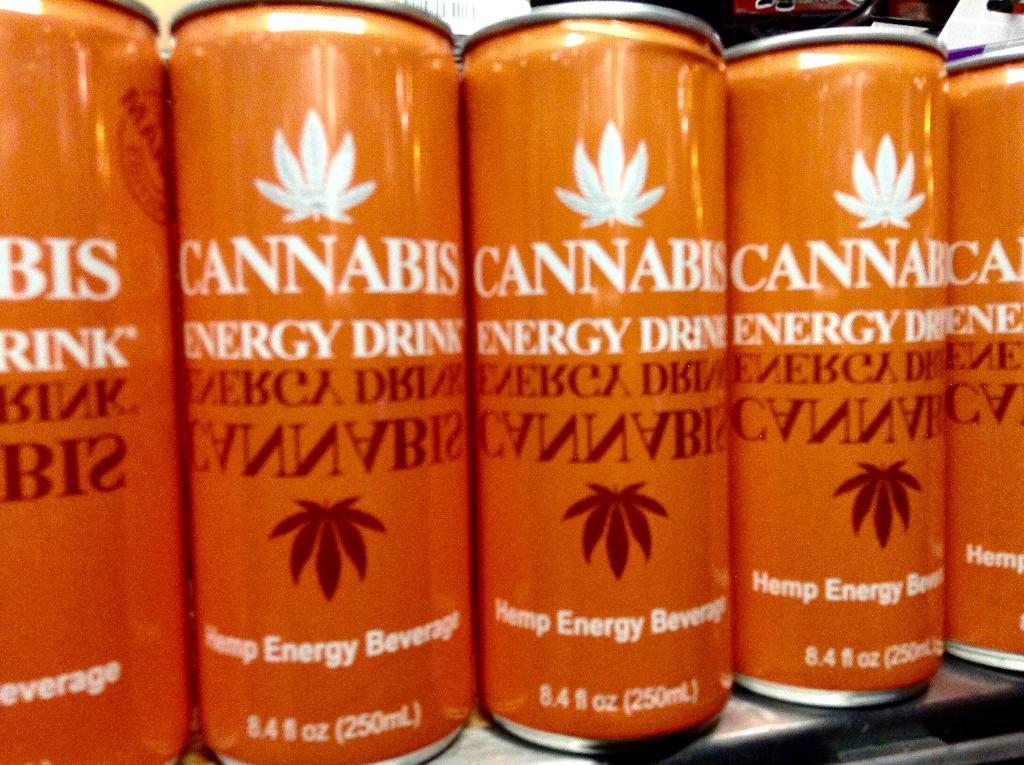Provide a one-sentence caption for the provided image. Cannabis energy drinks are lined up next to each other. 